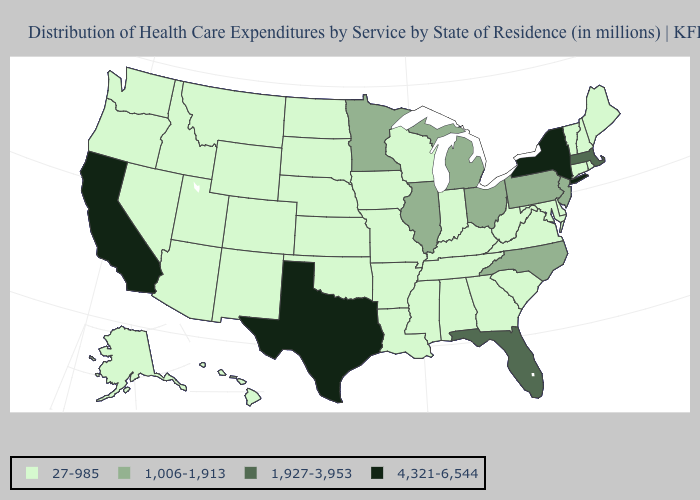Name the states that have a value in the range 1,006-1,913?
Keep it brief. Illinois, Michigan, Minnesota, New Jersey, North Carolina, Ohio, Pennsylvania. Among the states that border Maine , which have the lowest value?
Concise answer only. New Hampshire. Does the first symbol in the legend represent the smallest category?
Give a very brief answer. Yes. Is the legend a continuous bar?
Be succinct. No. Does Texas have the same value as California?
Concise answer only. Yes. Name the states that have a value in the range 4,321-6,544?
Keep it brief. California, New York, Texas. What is the lowest value in the USA?
Give a very brief answer. 27-985. What is the value of California?
Keep it brief. 4,321-6,544. What is the highest value in the MidWest ?
Write a very short answer. 1,006-1,913. Which states hav the highest value in the South?
Answer briefly. Texas. What is the lowest value in the Northeast?
Concise answer only. 27-985. Name the states that have a value in the range 27-985?
Concise answer only. Alabama, Alaska, Arizona, Arkansas, Colorado, Connecticut, Delaware, Georgia, Hawaii, Idaho, Indiana, Iowa, Kansas, Kentucky, Louisiana, Maine, Maryland, Mississippi, Missouri, Montana, Nebraska, Nevada, New Hampshire, New Mexico, North Dakota, Oklahoma, Oregon, Rhode Island, South Carolina, South Dakota, Tennessee, Utah, Vermont, Virginia, Washington, West Virginia, Wisconsin, Wyoming. Name the states that have a value in the range 4,321-6,544?
Concise answer only. California, New York, Texas. What is the value of New Mexico?
Write a very short answer. 27-985. Name the states that have a value in the range 1,006-1,913?
Give a very brief answer. Illinois, Michigan, Minnesota, New Jersey, North Carolina, Ohio, Pennsylvania. 